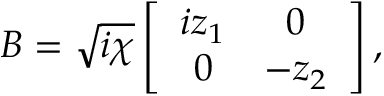Convert formula to latex. <formula><loc_0><loc_0><loc_500><loc_500>B = \sqrt { i \chi } \left [ \begin{array} { c c } { i z _ { 1 } } & { 0 } \\ { 0 } & { - z _ { 2 } } \end{array} \right ] ,</formula> 